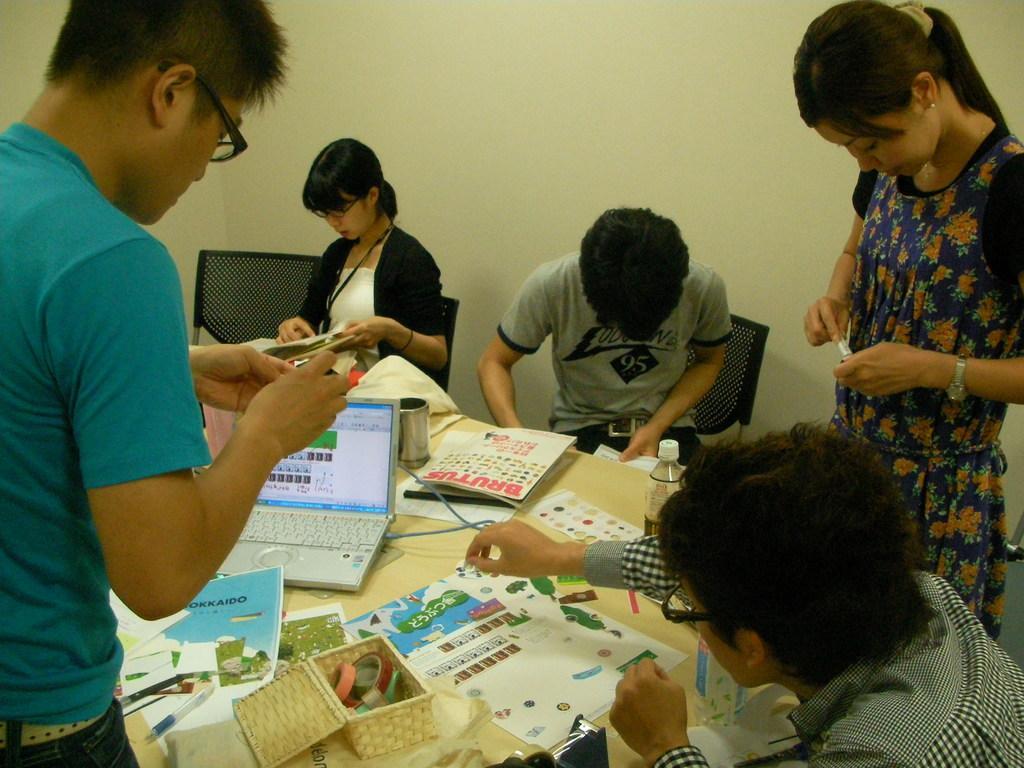Please provide a concise description of this image. In the background we can see the wall. In this picture we can see the people, chairs. People are performing some action. On the table we can see a laptop, papers, pens, bottle and few objects. 